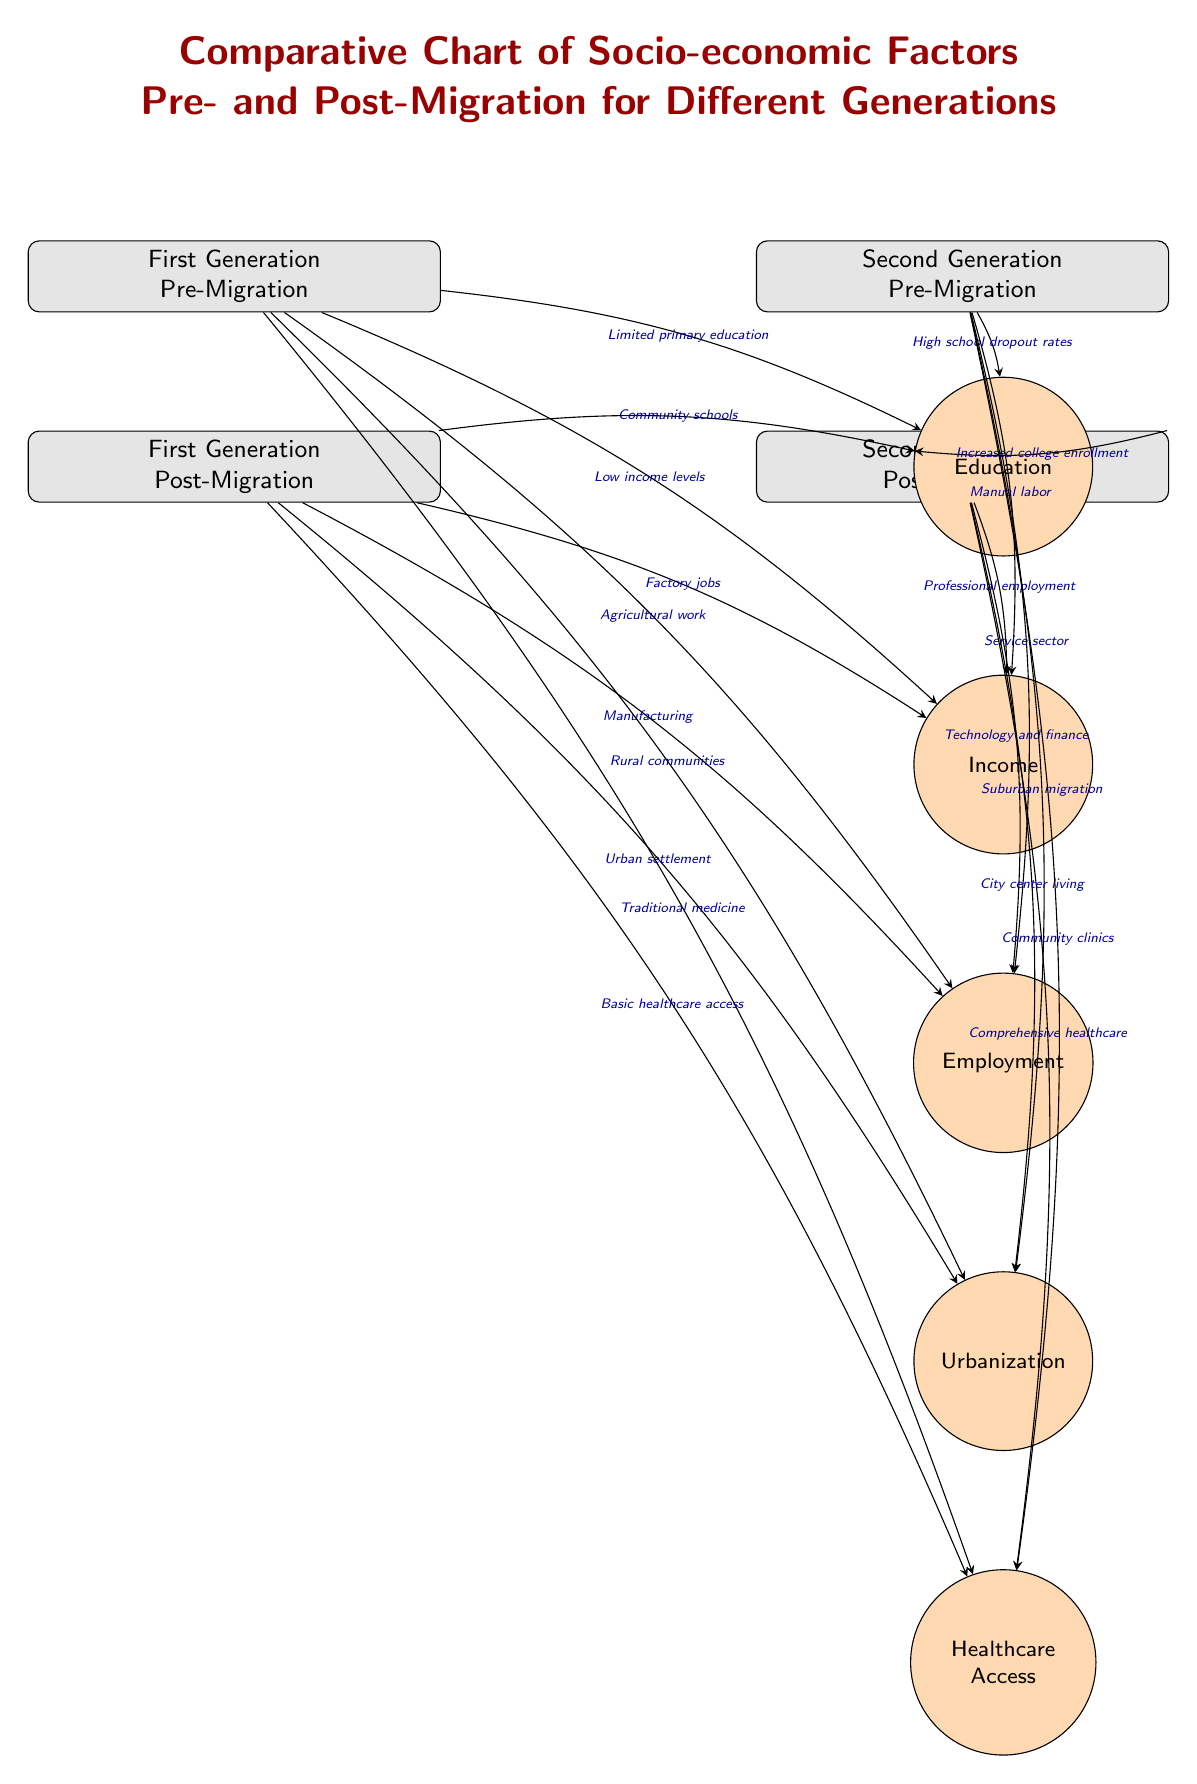What is the socio-economic factor linked to the first generation pre-migration with respect to employment? The node for the first generation pre-migration states "Agricultural work" under the Employment factor, indicating the type of work commonly associated with that generation before migration.
Answer: Agricultural work Which generation experienced increased college enrollment post-migration? The diagram indicates that the second generation post-migration is linked to "Increased college enrollment" under the Education factor, showcasing an improvement compared to their pre-migration status.
Answer: Second Generation How many socio-economic factors are listed in the diagram? The diagram features five socio-economic factors, which are Education, Income, Employment, Urbanization, and Healthcare Access. This is determined by counting the nodes labeled with the factor style.
Answer: Five What employment type is associated with the first generation post-migration? The node for the first generation post-migration states "Manufacturing" under the Employment factor, showing the shift in job type after migrating.
Answer: Manufacturing How does healthcare access improve from the first generation pre-migration to post-migration? For the first generation pre-migration, the diagram states "Traditional medicine" under Healthcare, while post-migration it improves to "Basic healthcare access," illustrating the shift from local practices to more formalized healthcare services.
Answer: Basic healthcare access 